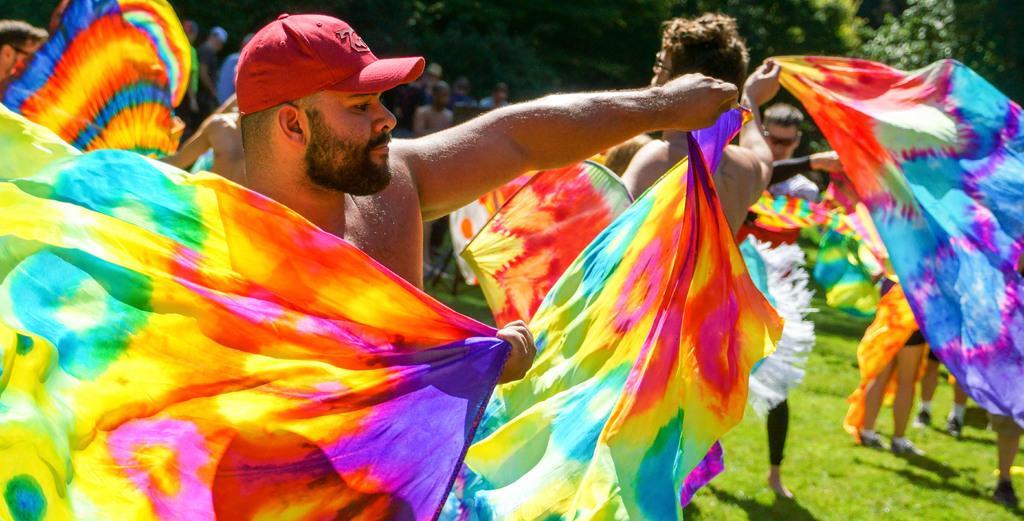Please provide a concise description of this image. There are people holding clothes and we can see grass. In the background we can see trees and people. 